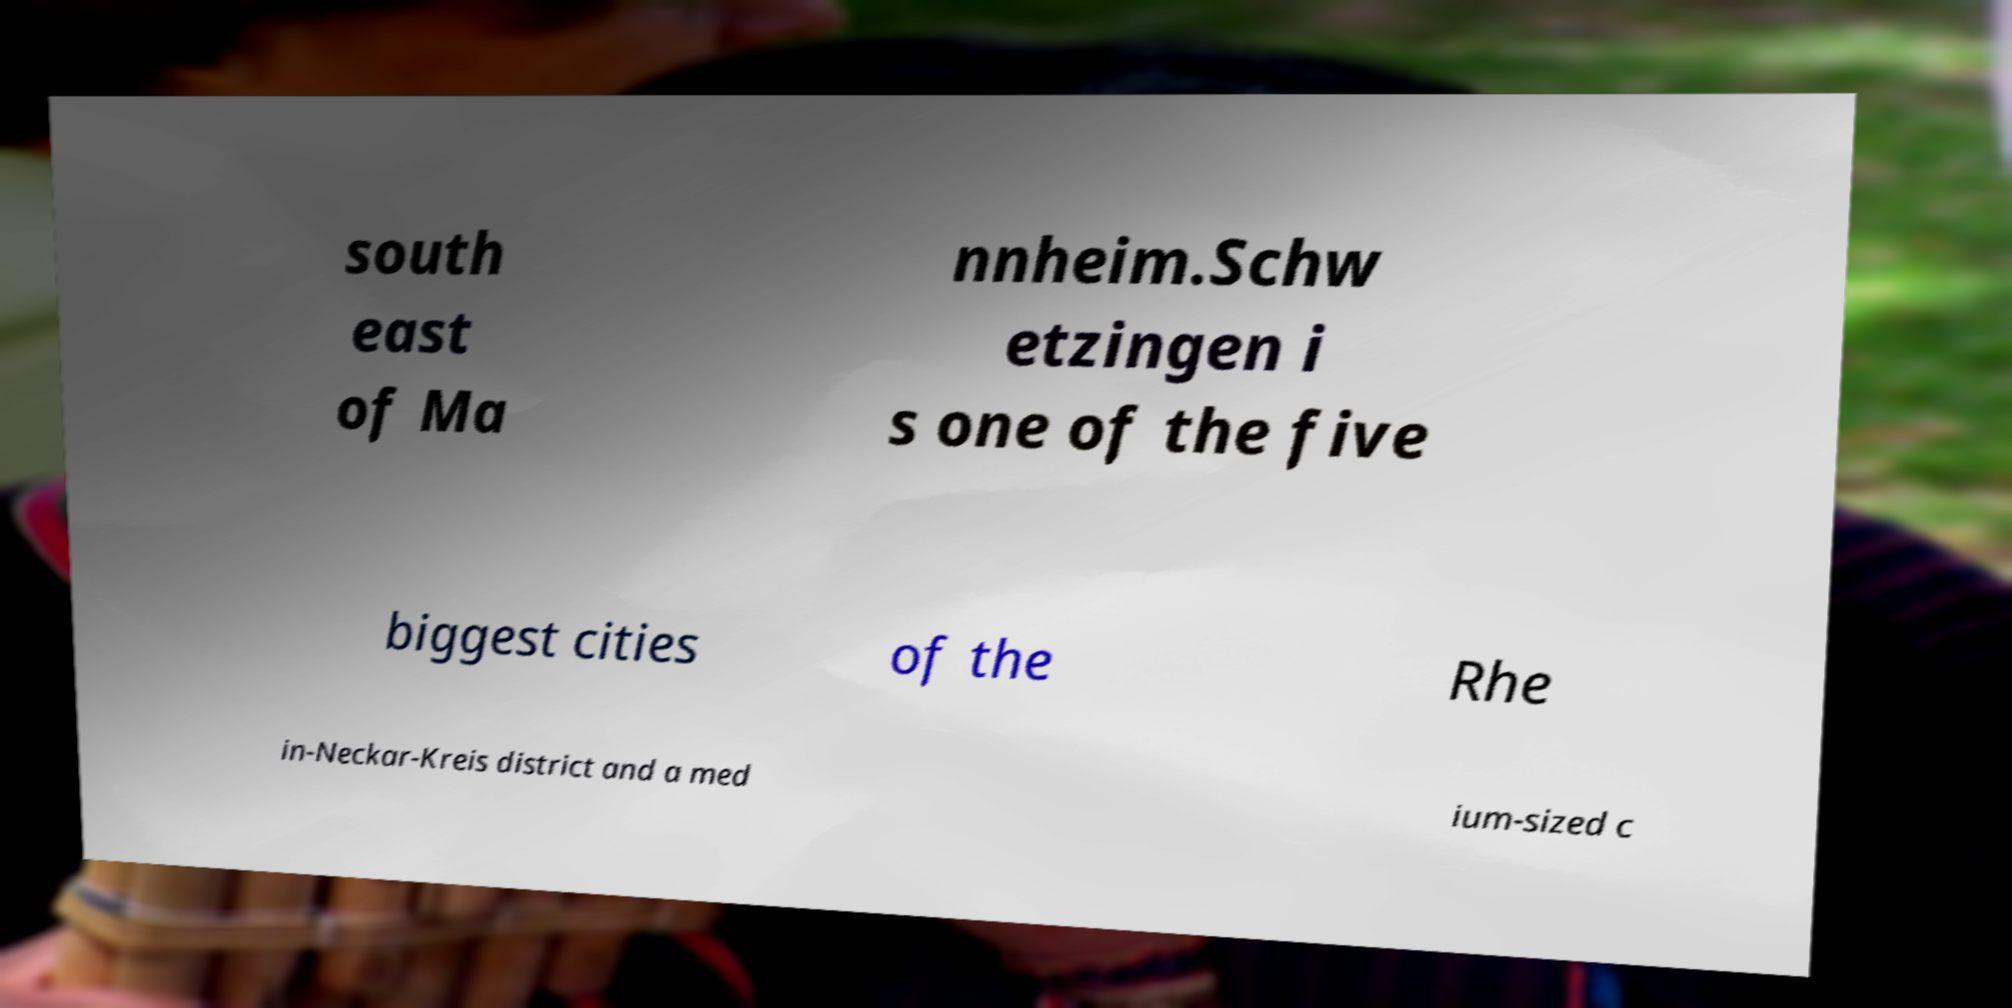For documentation purposes, I need the text within this image transcribed. Could you provide that? south east of Ma nnheim.Schw etzingen i s one of the five biggest cities of the Rhe in-Neckar-Kreis district and a med ium-sized c 